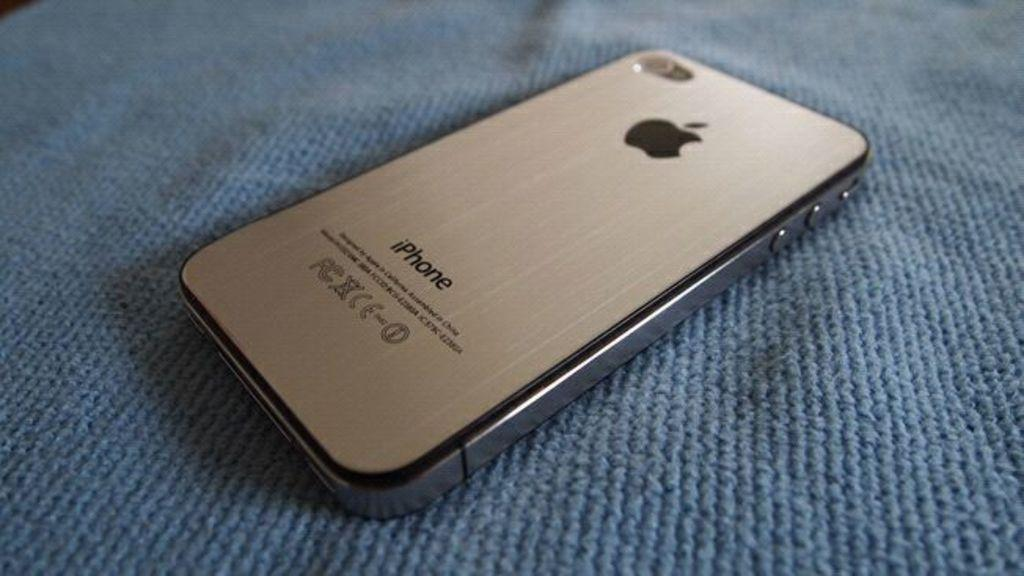<image>
Offer a succinct explanation of the picture presented. An iPhone sits face down on a blue cloth. 